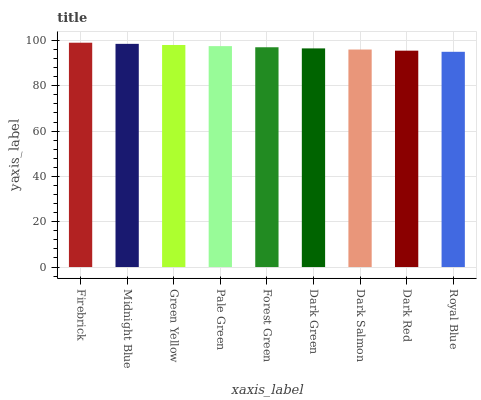Is Royal Blue the minimum?
Answer yes or no. Yes. Is Firebrick the maximum?
Answer yes or no. Yes. Is Midnight Blue the minimum?
Answer yes or no. No. Is Midnight Blue the maximum?
Answer yes or no. No. Is Firebrick greater than Midnight Blue?
Answer yes or no. Yes. Is Midnight Blue less than Firebrick?
Answer yes or no. Yes. Is Midnight Blue greater than Firebrick?
Answer yes or no. No. Is Firebrick less than Midnight Blue?
Answer yes or no. No. Is Forest Green the high median?
Answer yes or no. Yes. Is Forest Green the low median?
Answer yes or no. Yes. Is Dark Red the high median?
Answer yes or no. No. Is Green Yellow the low median?
Answer yes or no. No. 